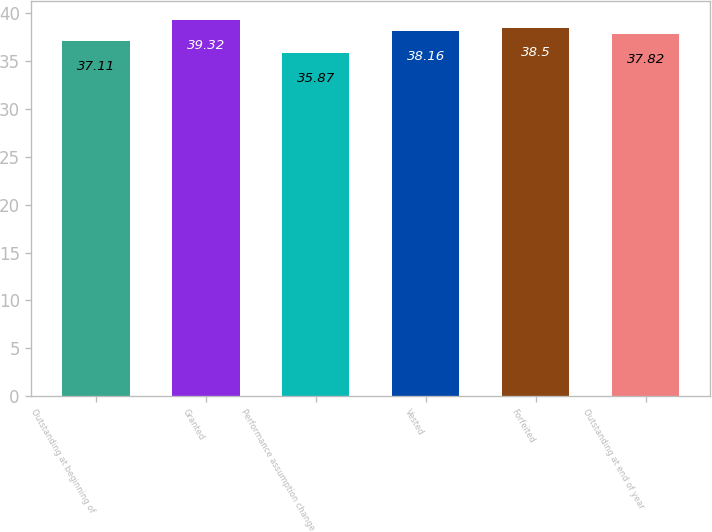Convert chart to OTSL. <chart><loc_0><loc_0><loc_500><loc_500><bar_chart><fcel>Outstanding at beginning of<fcel>Granted<fcel>Performance assumption change<fcel>Vested<fcel>Forfeited<fcel>Outstanding at end of year<nl><fcel>37.11<fcel>39.32<fcel>35.87<fcel>38.16<fcel>38.5<fcel>37.82<nl></chart> 